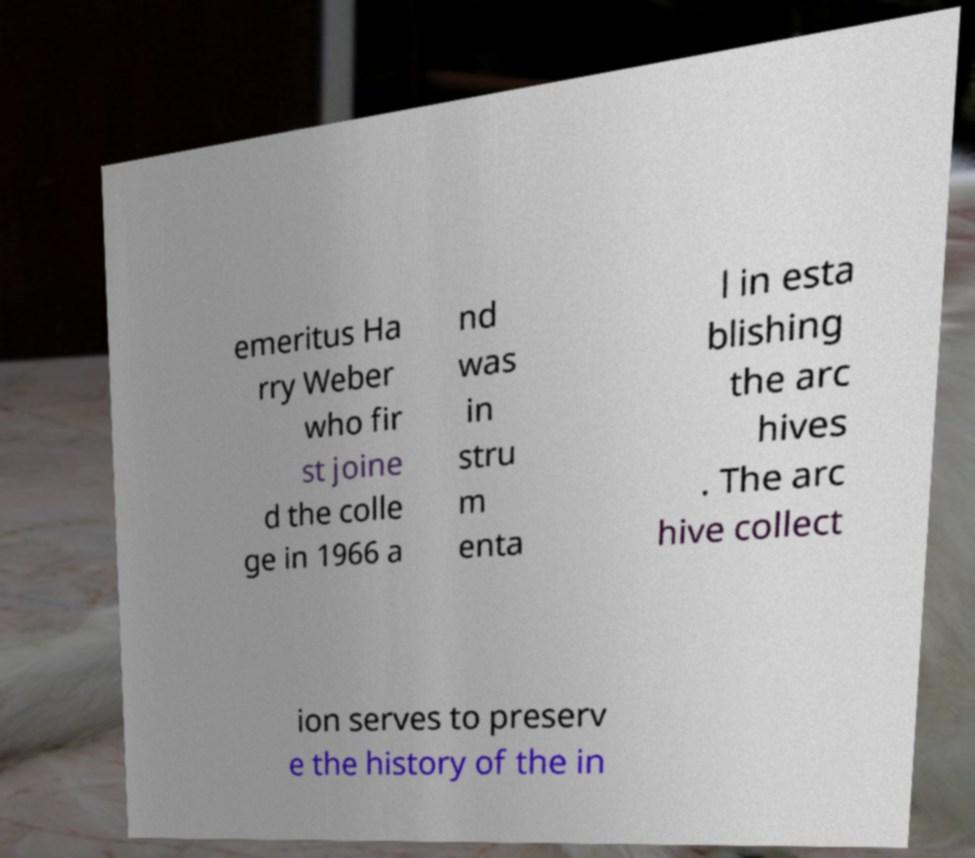There's text embedded in this image that I need extracted. Can you transcribe it verbatim? emeritus Ha rry Weber who fir st joine d the colle ge in 1966 a nd was in stru m enta l in esta blishing the arc hives . The arc hive collect ion serves to preserv e the history of the in 